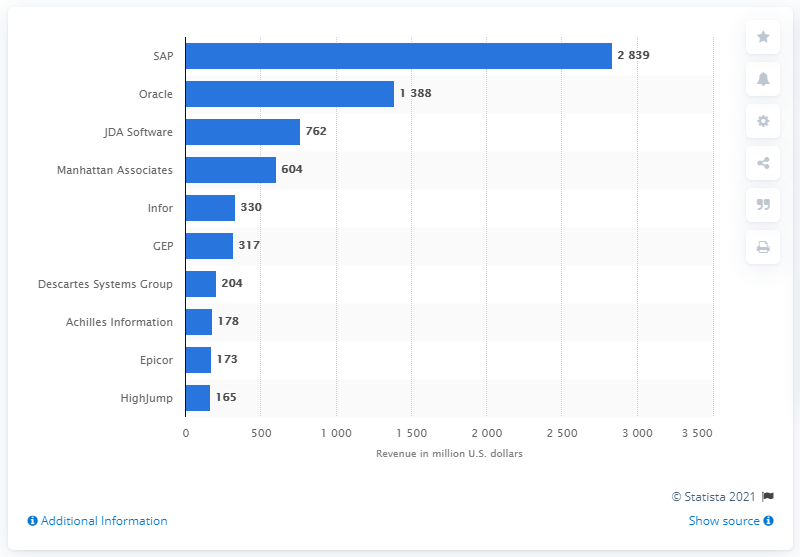Point out several critical features in this image. In the measured period, SAP's revenue was 2839. 